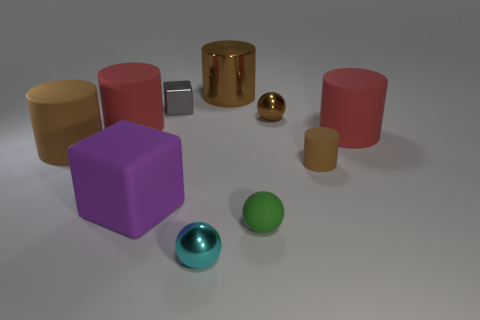The cyan sphere is what size?
Provide a short and direct response. Small. Is the purple object the same size as the green ball?
Give a very brief answer. No. There is a tiny gray shiny object; is its shape the same as the purple rubber object in front of the tiny gray thing?
Ensure brevity in your answer.  Yes. Are there the same number of gray blocks that are on the right side of the gray shiny cube and cyan spheres that are on the left side of the large block?
Ensure brevity in your answer.  Yes. The big matte object that is the same color as the small cylinder is what shape?
Ensure brevity in your answer.  Cylinder. There is a thing that is on the right side of the tiny matte cylinder; is it the same color as the small thing that is in front of the small green matte thing?
Make the answer very short. No. Are there more small cyan metal objects on the left side of the big purple matte object than big cyan matte things?
Your response must be concise. No. What is the material of the tiny green sphere?
Your answer should be compact. Rubber. The large brown thing that is the same material as the purple cube is what shape?
Ensure brevity in your answer.  Cylinder. There is a red rubber cylinder to the left of the tiny gray cube that is to the left of the tiny cylinder; what is its size?
Keep it short and to the point. Large. 